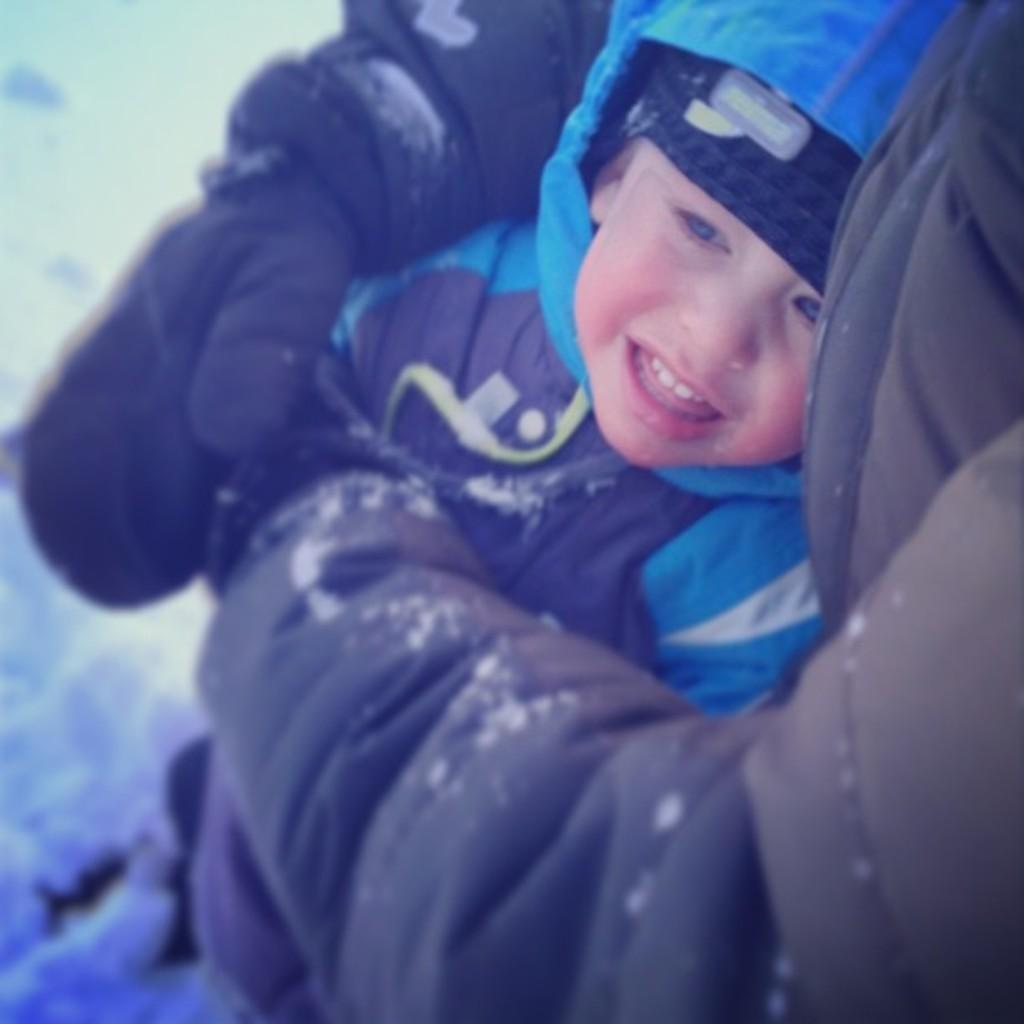What is happening in the foreground of the image? There is a person holding a boy in the foreground of the image. What can be seen in the background of the image? There is snow in the background of the image. What are the persons in the image wearing? The persons in the image are wearing jackets. What invention is the grandfather demonstrating to the boy in the image? There is no grandfather present in the image, and no invention is being demonstrated. 